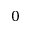<formula> <loc_0><loc_0><loc_500><loc_500>0</formula> 